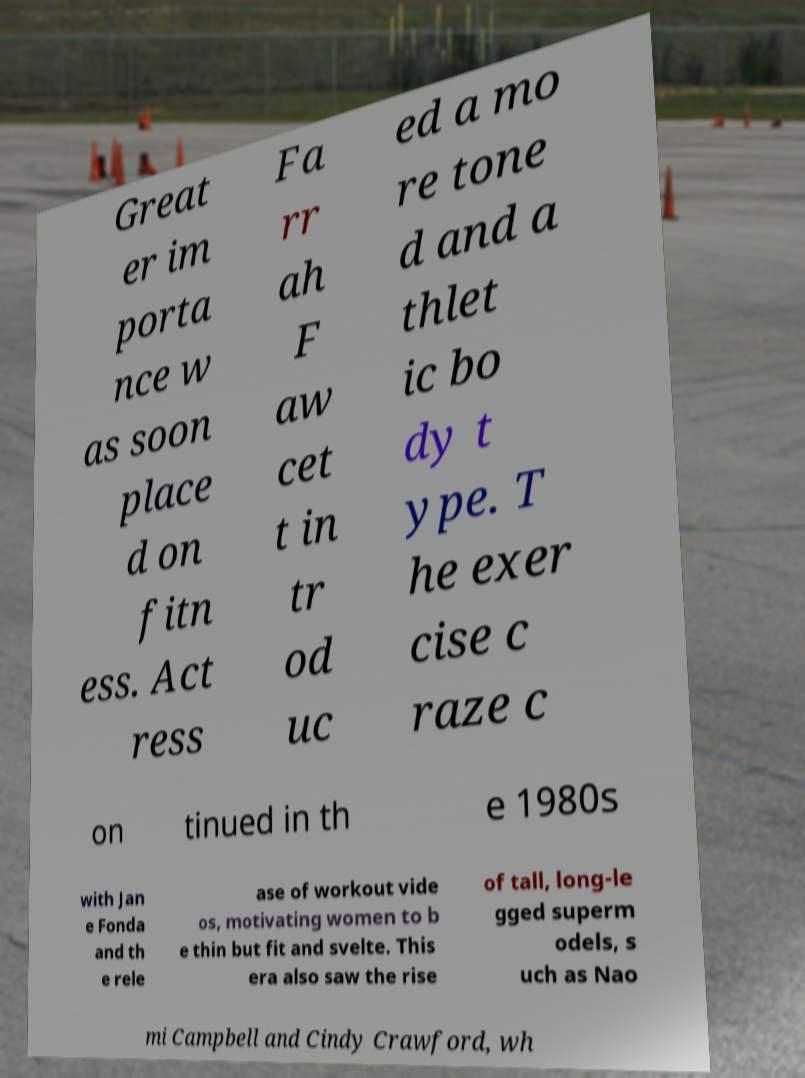There's text embedded in this image that I need extracted. Can you transcribe it verbatim? Great er im porta nce w as soon place d on fitn ess. Act ress Fa rr ah F aw cet t in tr od uc ed a mo re tone d and a thlet ic bo dy t ype. T he exer cise c raze c on tinued in th e 1980s with Jan e Fonda and th e rele ase of workout vide os, motivating women to b e thin but fit and svelte. This era also saw the rise of tall, long-le gged superm odels, s uch as Nao mi Campbell and Cindy Crawford, wh 